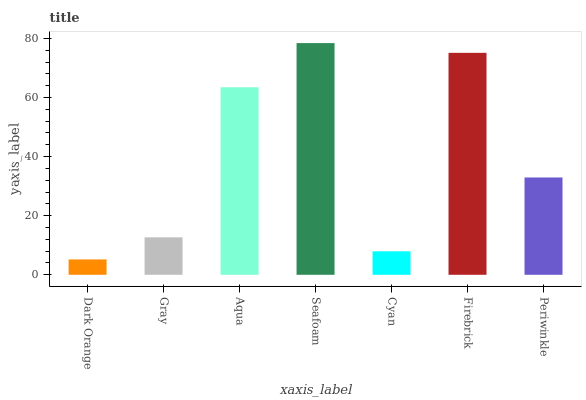Is Dark Orange the minimum?
Answer yes or no. Yes. Is Seafoam the maximum?
Answer yes or no. Yes. Is Gray the minimum?
Answer yes or no. No. Is Gray the maximum?
Answer yes or no. No. Is Gray greater than Dark Orange?
Answer yes or no. Yes. Is Dark Orange less than Gray?
Answer yes or no. Yes. Is Dark Orange greater than Gray?
Answer yes or no. No. Is Gray less than Dark Orange?
Answer yes or no. No. Is Periwinkle the high median?
Answer yes or no. Yes. Is Periwinkle the low median?
Answer yes or no. Yes. Is Firebrick the high median?
Answer yes or no. No. Is Gray the low median?
Answer yes or no. No. 